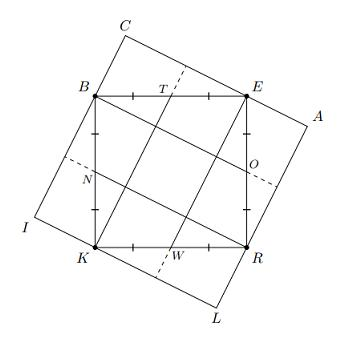Sohom constructs a square BERK of side length 10. Darlnim adds points T, O, W, and N, which are the midpoints of \overline{BE}, \overline{ER}, \overline{RK}, and \overline{KB}, respectively. Lastly, Sylvia constructs square CALI whose edges contain the vertices of BERK, such that \overline{CA} is parallel to \overline{BO}. Compute the area of CALI. To find the area of square CALI, first note that CALI is a rotated version of square BERK with the same side length, as it includes all vertices of BERK and \overline{CA} is parallel to \overline{BO}, which is a diagonal line in the interior of CALI due to O being a midpoint. The side length of square BERK is 10, thus CALI also has a side length of 10, making the area 10 x 10 = 100 square units. The area of square CALI is therefore 100 square units. 